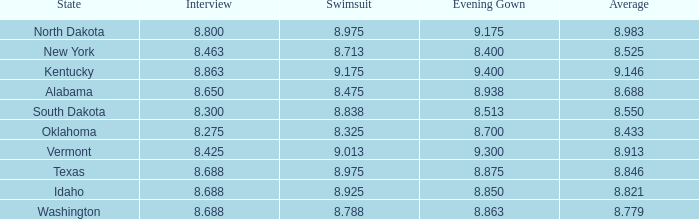513? None. 